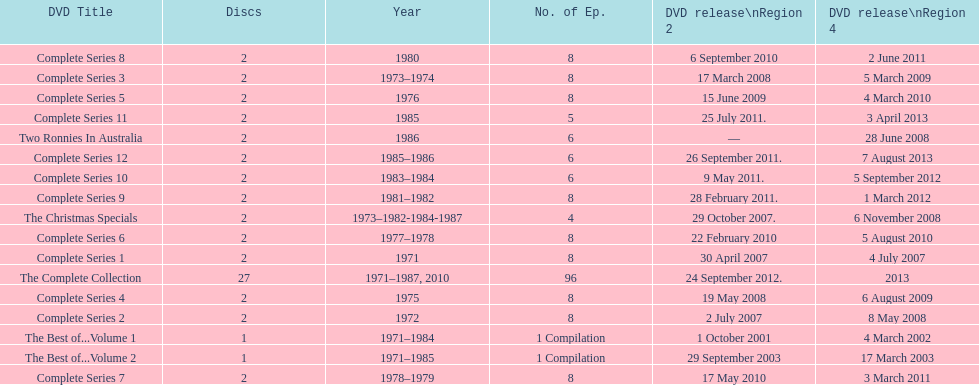Dvd shorter than 5 episodes The Christmas Specials. 